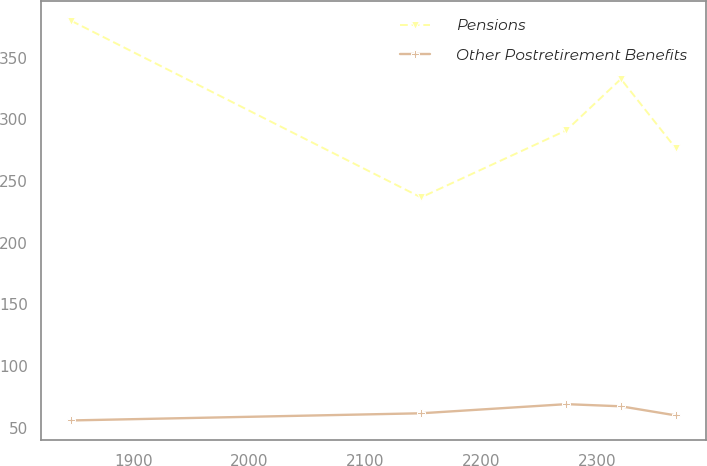Convert chart to OTSL. <chart><loc_0><loc_0><loc_500><loc_500><line_chart><ecel><fcel>Pensions<fcel>Other Postretirement Benefits<nl><fcel>1846.34<fcel>379.65<fcel>55.77<nl><fcel>2148.1<fcel>236.57<fcel>61.57<nl><fcel>2273.55<fcel>290.95<fcel>68.98<nl><fcel>2320.68<fcel>332.58<fcel>67.23<nl><fcel>2367.81<fcel>276.64<fcel>59.88<nl></chart> 